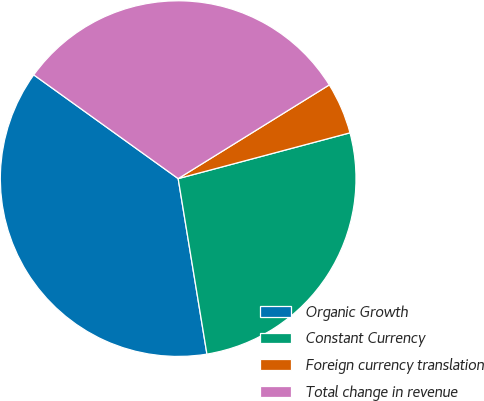<chart> <loc_0><loc_0><loc_500><loc_500><pie_chart><fcel>Organic Growth<fcel>Constant Currency<fcel>Foreign currency translation<fcel>Total change in revenue<nl><fcel>37.5%<fcel>26.56%<fcel>4.69%<fcel>31.25%<nl></chart> 